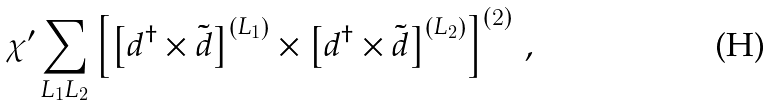Convert formula to latex. <formula><loc_0><loc_0><loc_500><loc_500>\chi ^ { \prime } \sum _ { L _ { 1 } L _ { 2 } } \left [ \left [ d ^ { \dag } \times \tilde { d } \right ] ^ { \left ( L _ { 1 } \right ) } \times \left [ d ^ { \dag } \times \tilde { d } \right ] ^ { \left ( L _ { 2 } \right ) } \right ] ^ { \left ( 2 \right ) } \, ,</formula> 